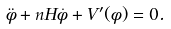<formula> <loc_0><loc_0><loc_500><loc_500>\ddot { \phi } + n H \dot { \phi } + V ^ { \prime } ( \phi ) = 0 .</formula> 